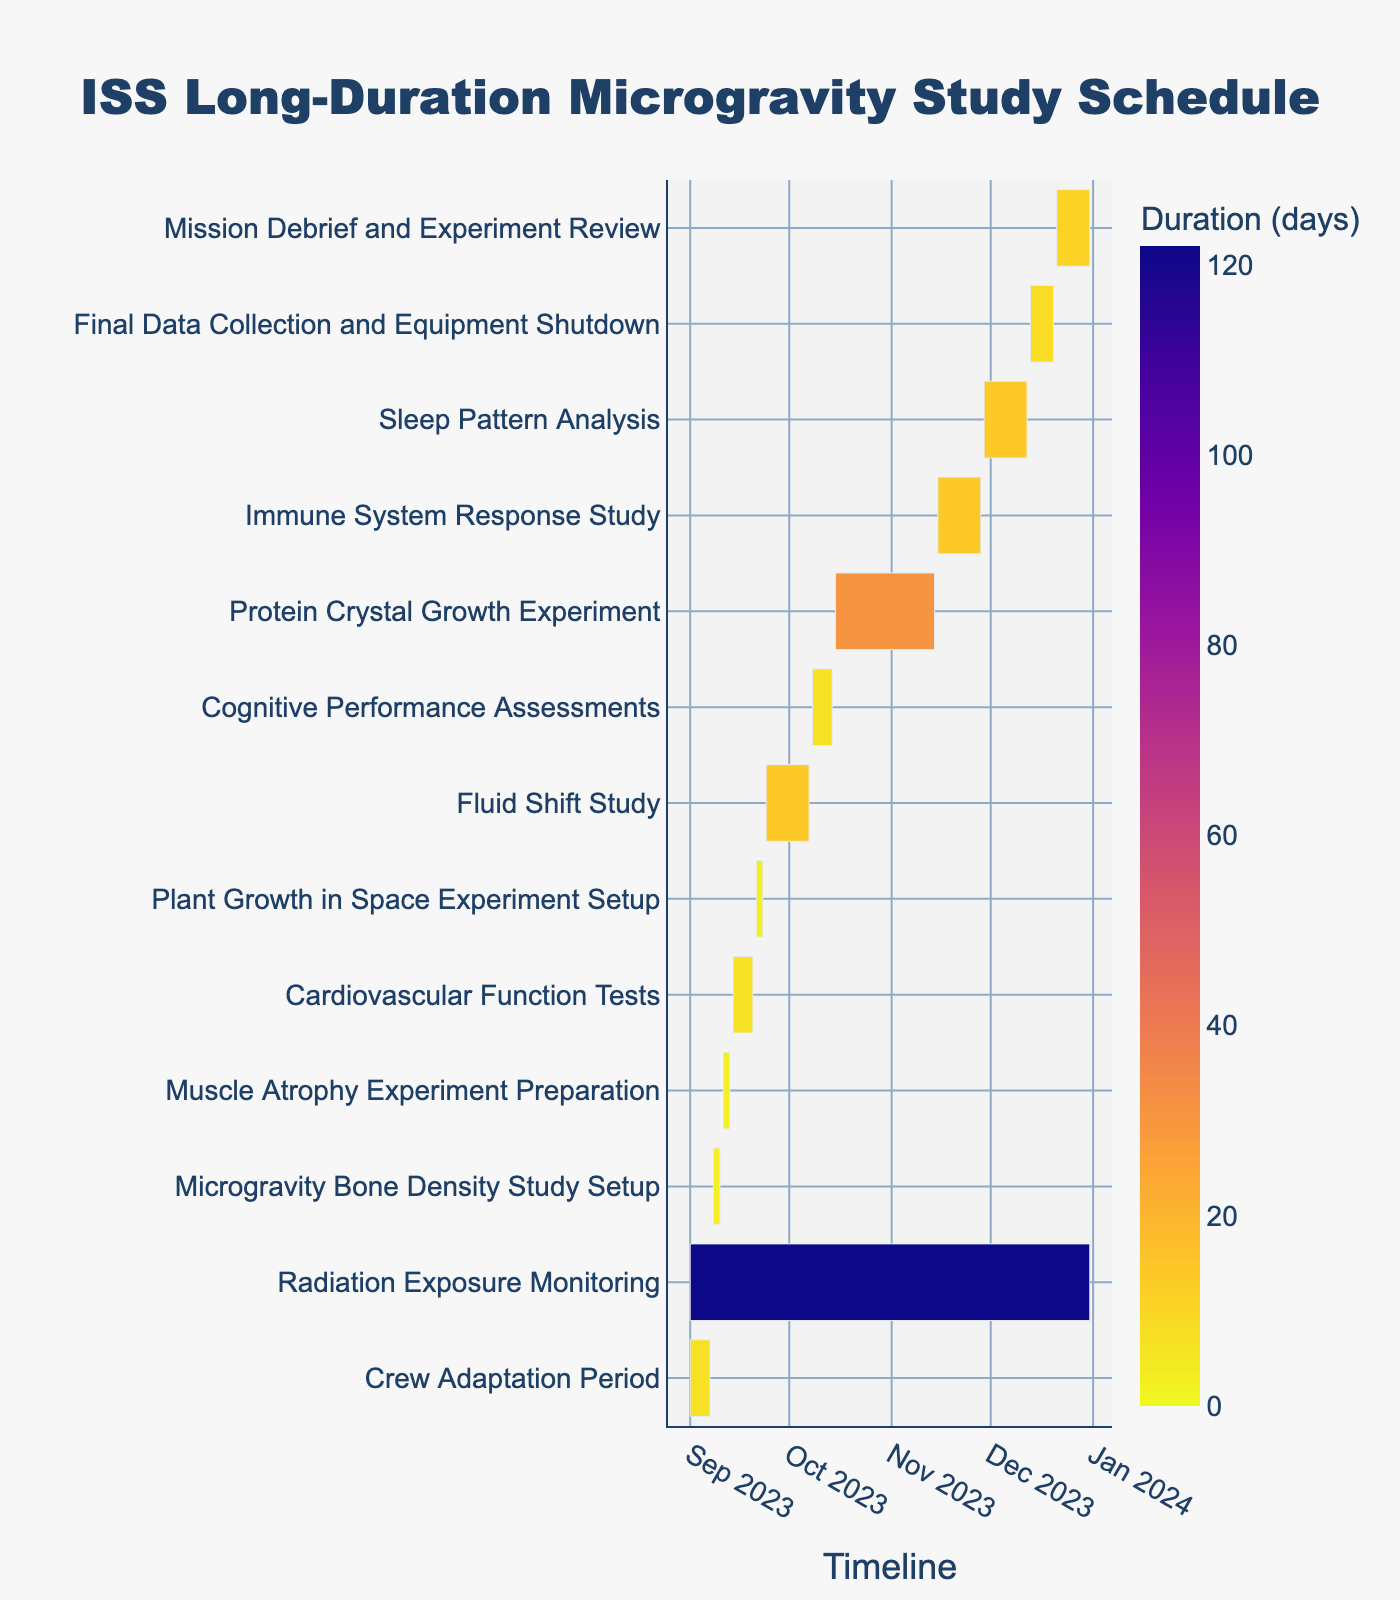What is the title of the Gantt Chart? The title of the Gantt Chart can be found at the top of the figure where the title is often situated and generally more prominent.
Answer: ISS Long-Duration Microgravity Study Schedule How long does the Radiation Exposure Monitoring task last? To determine the task duration, locate the Radiation Exposure Monitoring bar and use the color scale or dates on the x-axis to calculate the duration from start (2023-09-01) to end (2023-12-31).
Answer: 122 days Which task starts first? Identify the task with the earliest start date by looking at the left-most starting bar in the chart.
Answer: Crew Adaptation Period How many tasks have a duration of more than 10 days? Review each task’s duration and count those exceeding 10 days by using the color or the length of the bars relative to the x-axis dates.
Answer: 5 tasks Which task has the longest duration? Locate the task with the longest bar spanning the most days on the x-axis; this will indicate the longest duration.
Answer: Radiation Exposure Monitoring What is the duration difference between the Cognitive Performance Assessments and Sleep Pattern Analysis tasks? Identify the duration of both tasks from the chart, then subtract the duration of the Cognitive Performance Assessments (7 days) from the Sleep Pattern Analysis (14 days) to find the difference.
Answer: 7 days Which task ends on November 14, 2023? Scan the end dates along the x-axis and locate the task that ends precisely on the specified date.
Answer: Protein Crystal Growth Experiment During which period does the Fluid Shift Study take place? Observe the starting and ending dates of the Fluid Shift Study bar and read the corresponding dates on the x-axis.
Answer: 2023-09-24 to 2023-10-07 How many tasks are scheduled to start in November? Identify and count the bars that begin in November by checking the start dates along the x-axis.
Answer: 3 tasks Which task immediately follows the Muscle Atrophy Experiment Preparation? Look for the end date of the Muscle Atrophy Experiment Preparation and find the next task that starts right after it ends.
Answer: Cardiovascular Function Tests 